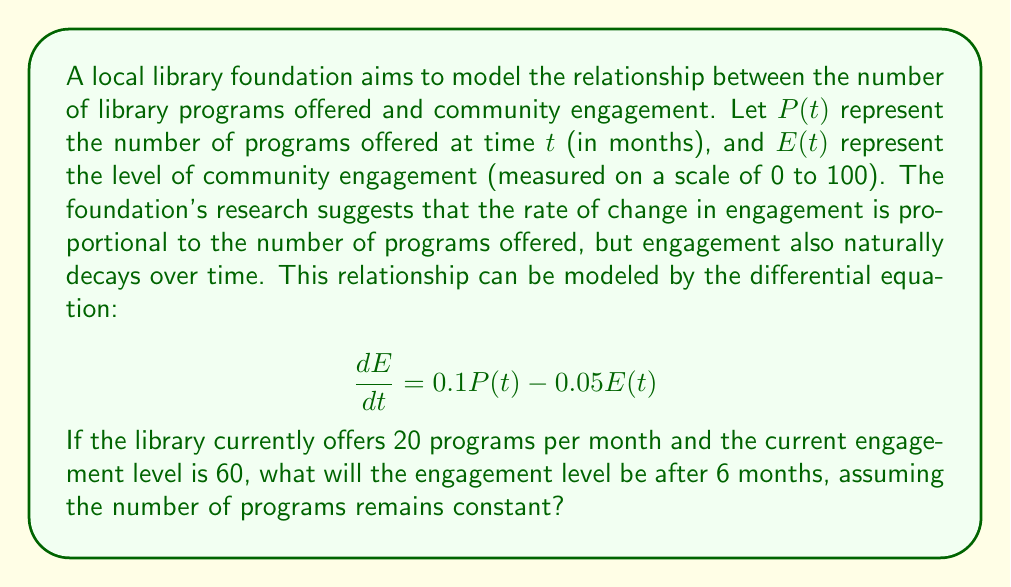Could you help me with this problem? To solve this problem, we need to follow these steps:

1) First, we recognize that this is a first-order linear differential equation.

2) Since $P(t)$ is constant at 20, our equation becomes:

   $$\frac{dE}{dt} = 0.1(20) - 0.05E(t) = 2 - 0.05E(t)$$

3) This is in the standard form of $\frac{dy}{dx} + P(x)y = Q(x)$, where:
   
   $P(x) = 0.05$ and $Q(x) = 2$

4) The general solution to this type of equation is:

   $$E(t) = e^{-\int P(x)dx}(\int Q(x)e^{\int P(x)dx}dx + C)$$

5) Solving the integrals:

   $\int P(x)dx = \int 0.05 dt = 0.05t$
   
   $e^{\int P(x)dx} = e^{0.05t}$

6) Substituting into the general solution:

   $$E(t) = e^{-0.05t}(\int 2e^{0.05t}dt + C)$$

7) Solving the integral:

   $$E(t) = e^{-0.05t}(\frac{2}{0.05}e^{0.05t} + C) = 40 + Ce^{-0.05t}$$

8) Using the initial condition $E(0) = 60$, we can find $C$:

   $60 = 40 + C$
   $C = 20$

9) Therefore, the particular solution is:

   $$E(t) = 40 + 20e^{-0.05t}$$

10) To find $E(6)$, we substitute $t = 6$:

    $$E(6) = 40 + 20e^{-0.05(6)} = 40 + 20e^{-0.3} \approx 54.81$$
Answer: After 6 months, the engagement level will be approximately 54.81. 